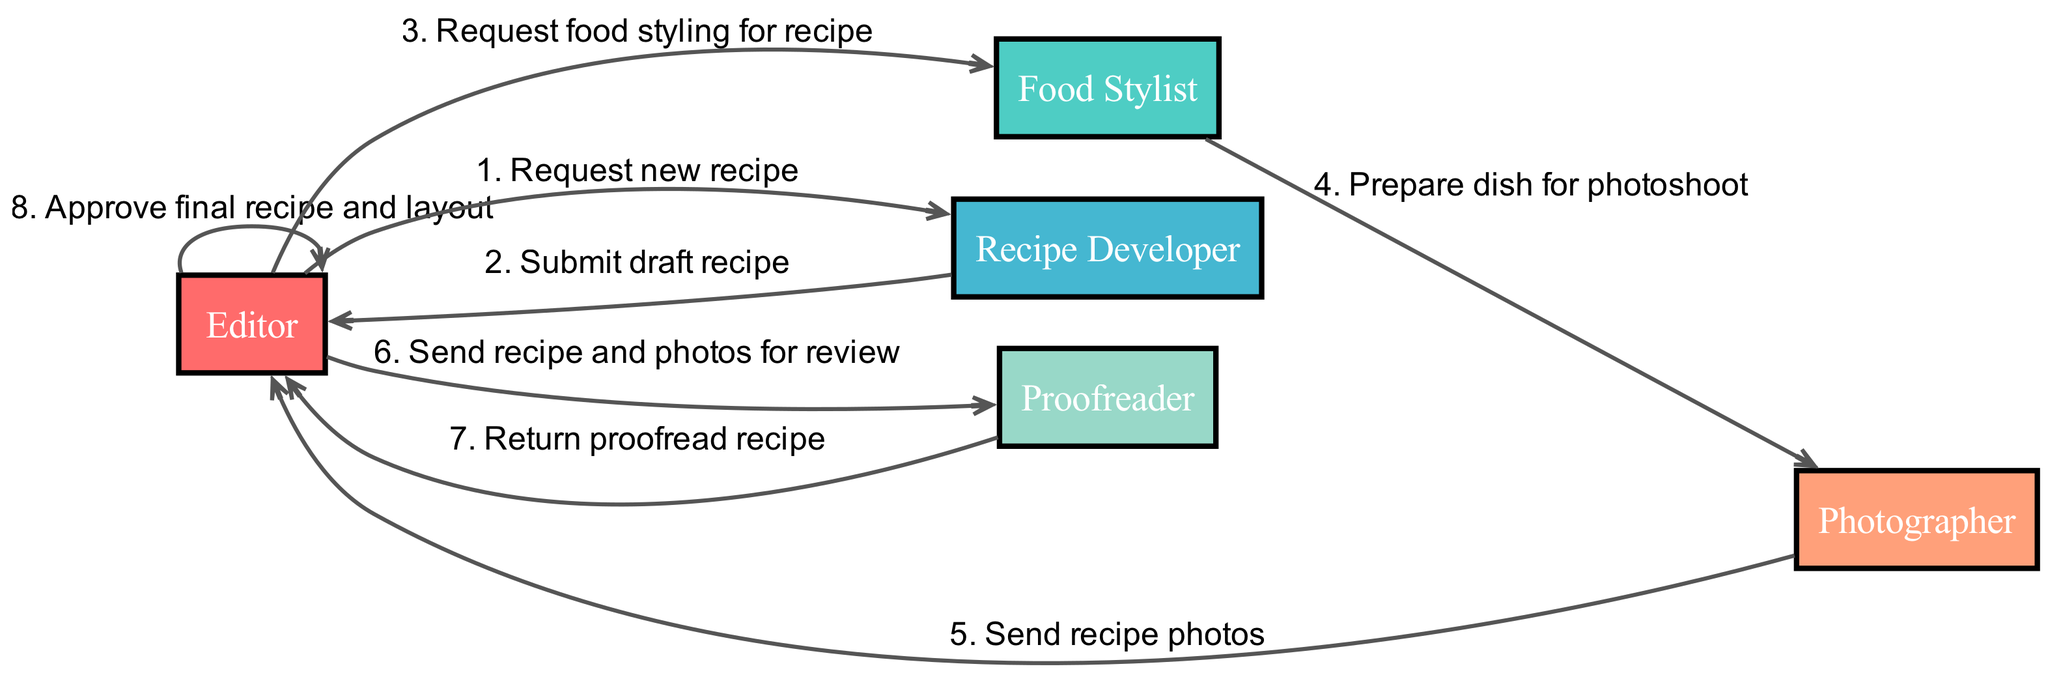What is the first message in the sequence? The diagram's sequence starts with the Editor sending a request for a new recipe to the Recipe Developer. This is the first message listed in the sequence.
Answer: Request new recipe How many actors are involved in the workflow? By counting the names listed in the "actors" section, we can see there are five distinct roles participating in the workflow.
Answer: Five Who is responsible for sending recipe photos to the Editor? The sequence indicates that the Photographer sends recipe photos directly to the Editor after preparing the dish for the photoshoot.
Answer: Photographer What is the last action taken in the sequence? The final action in the sequence shows the Editor approving the final recipe and layout after reviewing the proofread recipe returned from the Proofreader.
Answer: Approve final recipe and layout Which actor does the Food Stylist communicate with after preparing the dish? According to the sequence, the Food Stylist prepares the dish and then communicates with the Photographer to send the prepared dish for the photoshoot.
Answer: Photographer How many messages are exchanged before the Editor approves the final recipe? Counting all the messages listed in the sequence prior to the Editor's approval reveals that there are six messages exchanged before this approval action.
Answer: Six What role does the Proofreader play in the workflow? The Proofreader reviews the recipe and photos sent to them by the Editor and then returns the proofread document to the Editor, ensuring everything is accurate before approval.
Answer: Review recipe What does the Editor do after receiving the proofread recipe? After receiving the proofread recipe from the Proofreader, the Editor's next action is to approve the final recipe and layout, wrapping up the workflow.
Answer: Approve final recipe and layout Which actor is involved last in the sequence before the Editor's approval? Prior to the Editor’s approval, the last actor to be involved is the Proofreader, who returns the proofread recipe to the Editor.
Answer: Proofreader 